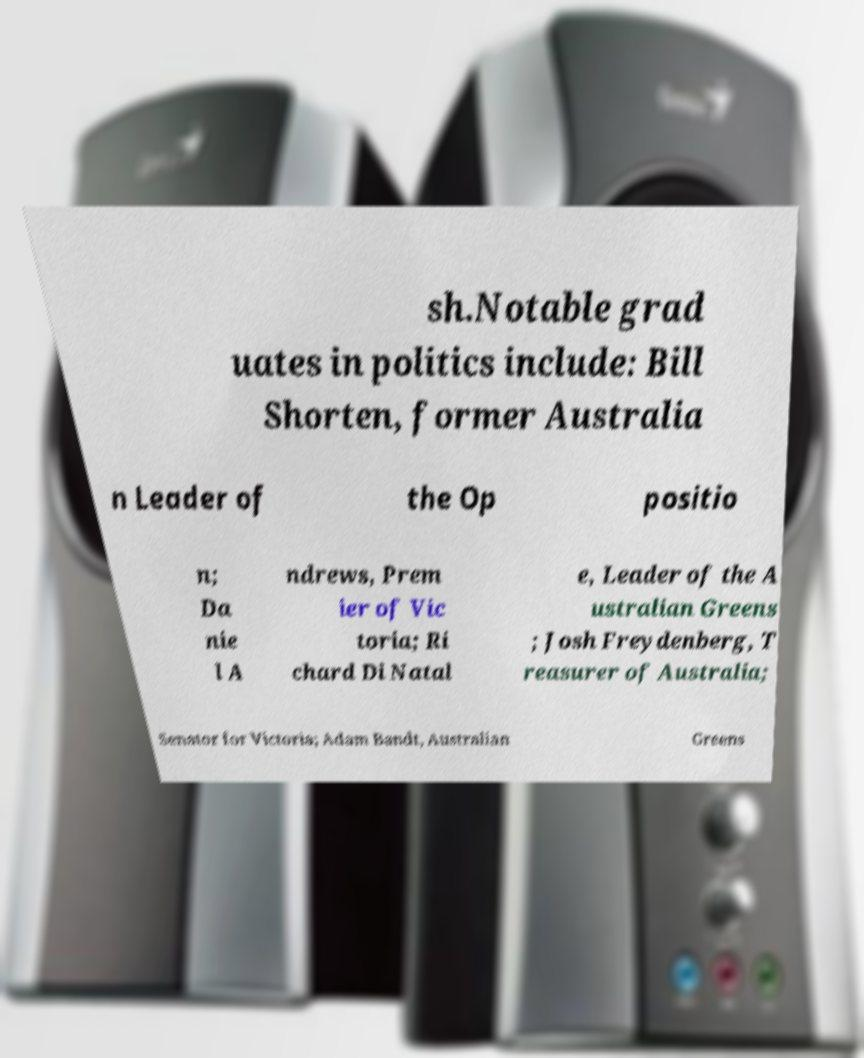I need the written content from this picture converted into text. Can you do that? sh.Notable grad uates in politics include: Bill Shorten, former Australia n Leader of the Op positio n; Da nie l A ndrews, Prem ier of Vic toria; Ri chard Di Natal e, Leader of the A ustralian Greens ; Josh Freydenberg, T reasurer of Australia; Senator for Victoria; Adam Bandt, Australian Greens 